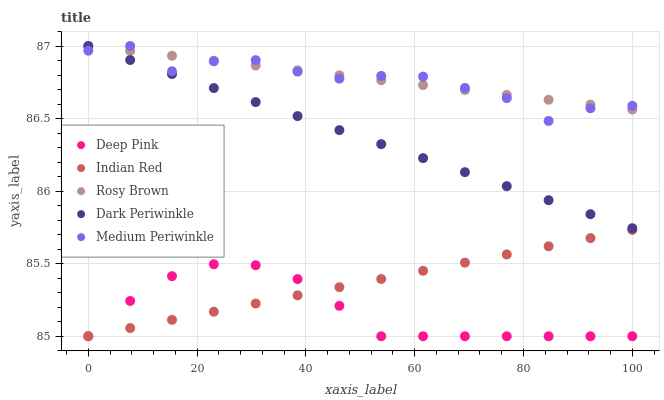Does Deep Pink have the minimum area under the curve?
Answer yes or no. Yes. Does Rosy Brown have the maximum area under the curve?
Answer yes or no. Yes. Does Medium Periwinkle have the minimum area under the curve?
Answer yes or no. No. Does Medium Periwinkle have the maximum area under the curve?
Answer yes or no. No. Is Rosy Brown the smoothest?
Answer yes or no. Yes. Is Medium Periwinkle the roughest?
Answer yes or no. Yes. Is Deep Pink the smoothest?
Answer yes or no. No. Is Deep Pink the roughest?
Answer yes or no. No. Does Deep Pink have the lowest value?
Answer yes or no. Yes. Does Medium Periwinkle have the lowest value?
Answer yes or no. No. Does Dark Periwinkle have the highest value?
Answer yes or no. Yes. Does Deep Pink have the highest value?
Answer yes or no. No. Is Indian Red less than Dark Periwinkle?
Answer yes or no. Yes. Is Medium Periwinkle greater than Indian Red?
Answer yes or no. Yes. Does Medium Periwinkle intersect Dark Periwinkle?
Answer yes or no. Yes. Is Medium Periwinkle less than Dark Periwinkle?
Answer yes or no. No. Is Medium Periwinkle greater than Dark Periwinkle?
Answer yes or no. No. Does Indian Red intersect Dark Periwinkle?
Answer yes or no. No. 